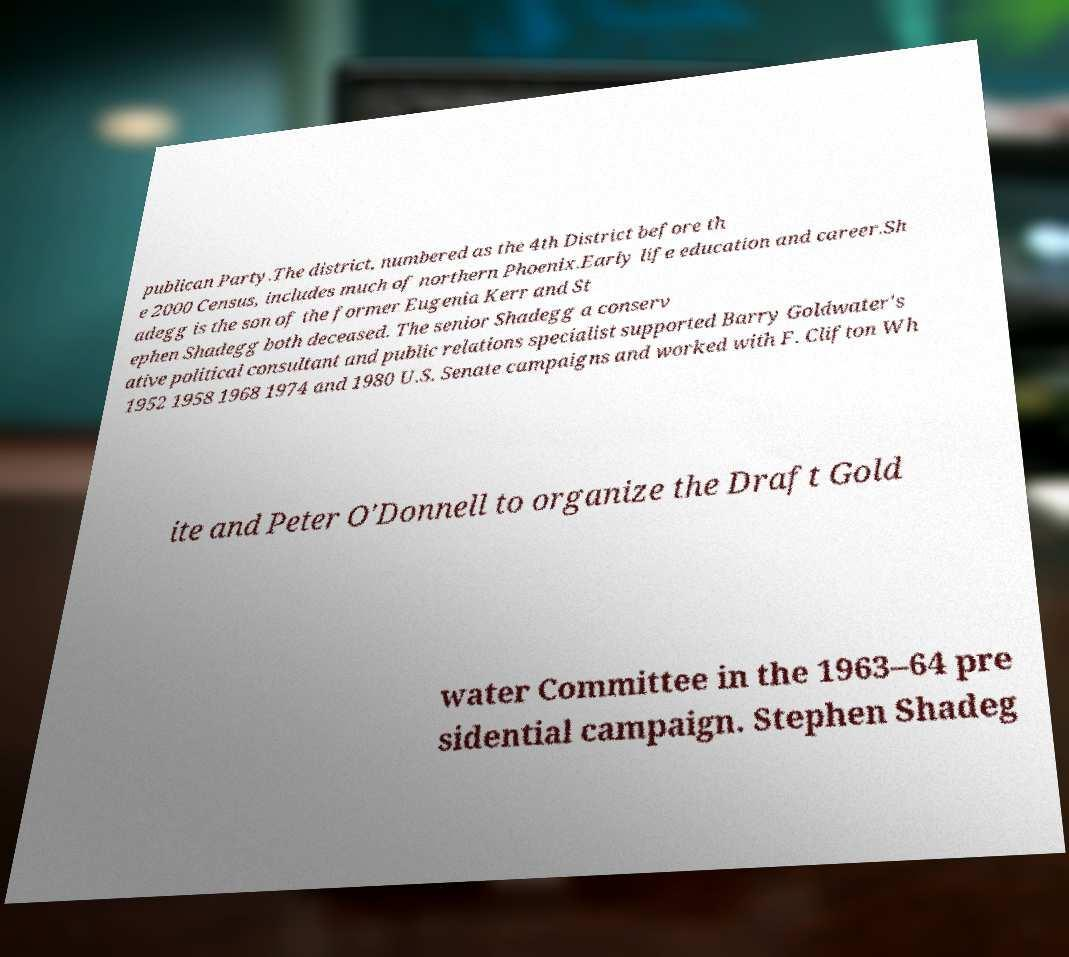For documentation purposes, I need the text within this image transcribed. Could you provide that? publican Party.The district, numbered as the 4th District before th e 2000 Census, includes much of northern Phoenix.Early life education and career.Sh adegg is the son of the former Eugenia Kerr and St ephen Shadegg both deceased. The senior Shadegg a conserv ative political consultant and public relations specialist supported Barry Goldwater's 1952 1958 1968 1974 and 1980 U.S. Senate campaigns and worked with F. Clifton Wh ite and Peter O'Donnell to organize the Draft Gold water Committee in the 1963–64 pre sidential campaign. Stephen Shadeg 